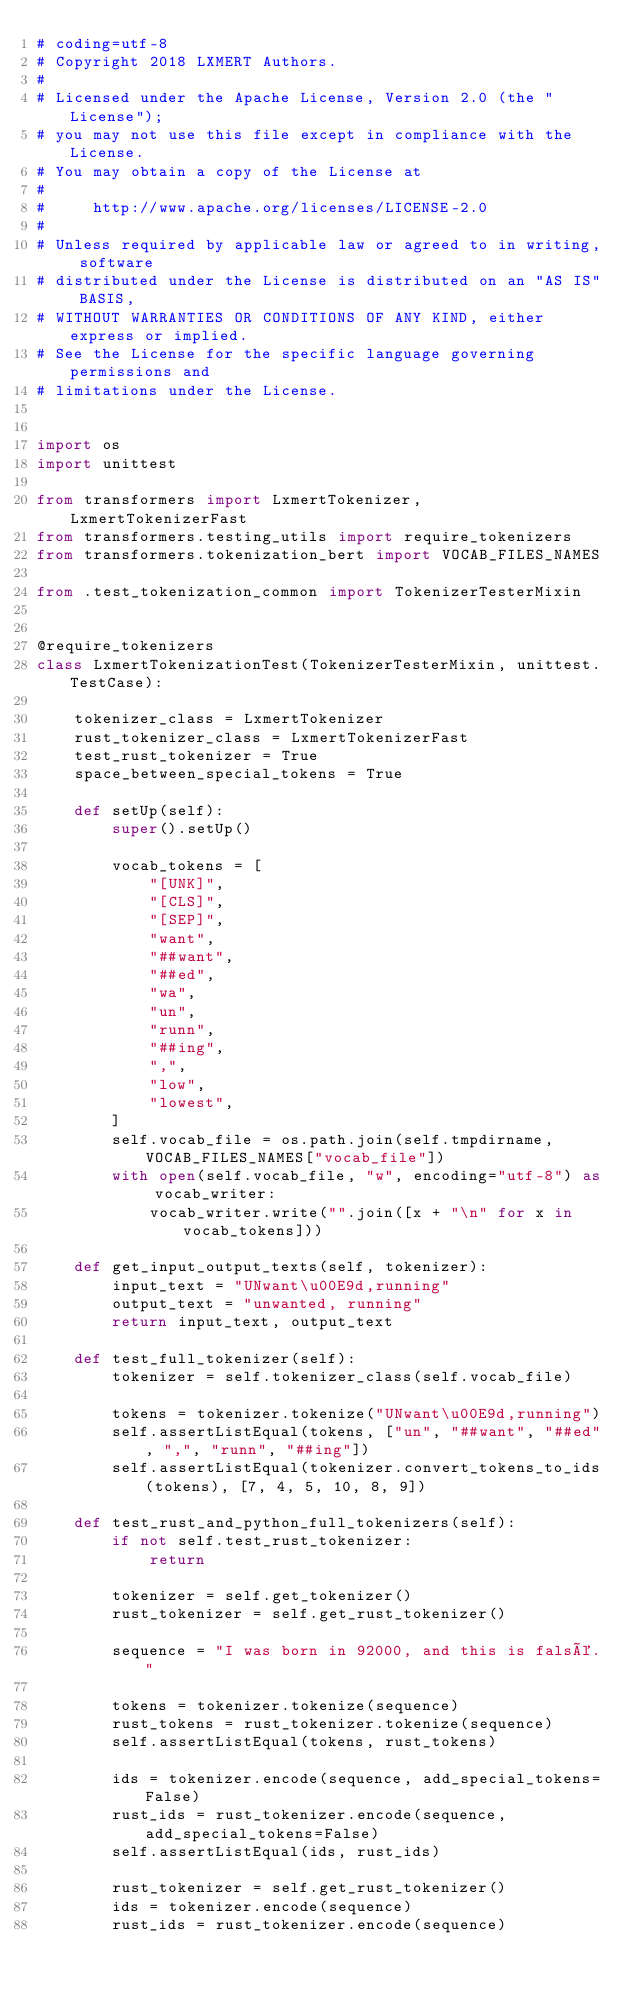<code> <loc_0><loc_0><loc_500><loc_500><_Python_># coding=utf-8
# Copyright 2018 LXMERT Authors.
#
# Licensed under the Apache License, Version 2.0 (the "License");
# you may not use this file except in compliance with the License.
# You may obtain a copy of the License at
#
#     http://www.apache.org/licenses/LICENSE-2.0
#
# Unless required by applicable law or agreed to in writing, software
# distributed under the License is distributed on an "AS IS" BASIS,
# WITHOUT WARRANTIES OR CONDITIONS OF ANY KIND, either express or implied.
# See the License for the specific language governing permissions and
# limitations under the License.


import os
import unittest

from transformers import LxmertTokenizer, LxmertTokenizerFast
from transformers.testing_utils import require_tokenizers
from transformers.tokenization_bert import VOCAB_FILES_NAMES

from .test_tokenization_common import TokenizerTesterMixin


@require_tokenizers
class LxmertTokenizationTest(TokenizerTesterMixin, unittest.TestCase):

    tokenizer_class = LxmertTokenizer
    rust_tokenizer_class = LxmertTokenizerFast
    test_rust_tokenizer = True
    space_between_special_tokens = True

    def setUp(self):
        super().setUp()

        vocab_tokens = [
            "[UNK]",
            "[CLS]",
            "[SEP]",
            "want",
            "##want",
            "##ed",
            "wa",
            "un",
            "runn",
            "##ing",
            ",",
            "low",
            "lowest",
        ]
        self.vocab_file = os.path.join(self.tmpdirname, VOCAB_FILES_NAMES["vocab_file"])
        with open(self.vocab_file, "w", encoding="utf-8") as vocab_writer:
            vocab_writer.write("".join([x + "\n" for x in vocab_tokens]))

    def get_input_output_texts(self, tokenizer):
        input_text = "UNwant\u00E9d,running"
        output_text = "unwanted, running"
        return input_text, output_text

    def test_full_tokenizer(self):
        tokenizer = self.tokenizer_class(self.vocab_file)

        tokens = tokenizer.tokenize("UNwant\u00E9d,running")
        self.assertListEqual(tokens, ["un", "##want", "##ed", ",", "runn", "##ing"])
        self.assertListEqual(tokenizer.convert_tokens_to_ids(tokens), [7, 4, 5, 10, 8, 9])

    def test_rust_and_python_full_tokenizers(self):
        if not self.test_rust_tokenizer:
            return

        tokenizer = self.get_tokenizer()
        rust_tokenizer = self.get_rust_tokenizer()

        sequence = "I was born in 92000, and this is falsé."

        tokens = tokenizer.tokenize(sequence)
        rust_tokens = rust_tokenizer.tokenize(sequence)
        self.assertListEqual(tokens, rust_tokens)

        ids = tokenizer.encode(sequence, add_special_tokens=False)
        rust_ids = rust_tokenizer.encode(sequence, add_special_tokens=False)
        self.assertListEqual(ids, rust_ids)

        rust_tokenizer = self.get_rust_tokenizer()
        ids = tokenizer.encode(sequence)
        rust_ids = rust_tokenizer.encode(sequence)</code> 